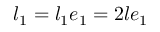<formula> <loc_0><loc_0><loc_500><loc_500>l _ { 1 } = l _ { 1 } e _ { 1 } = 2 l e _ { 1 }</formula> 